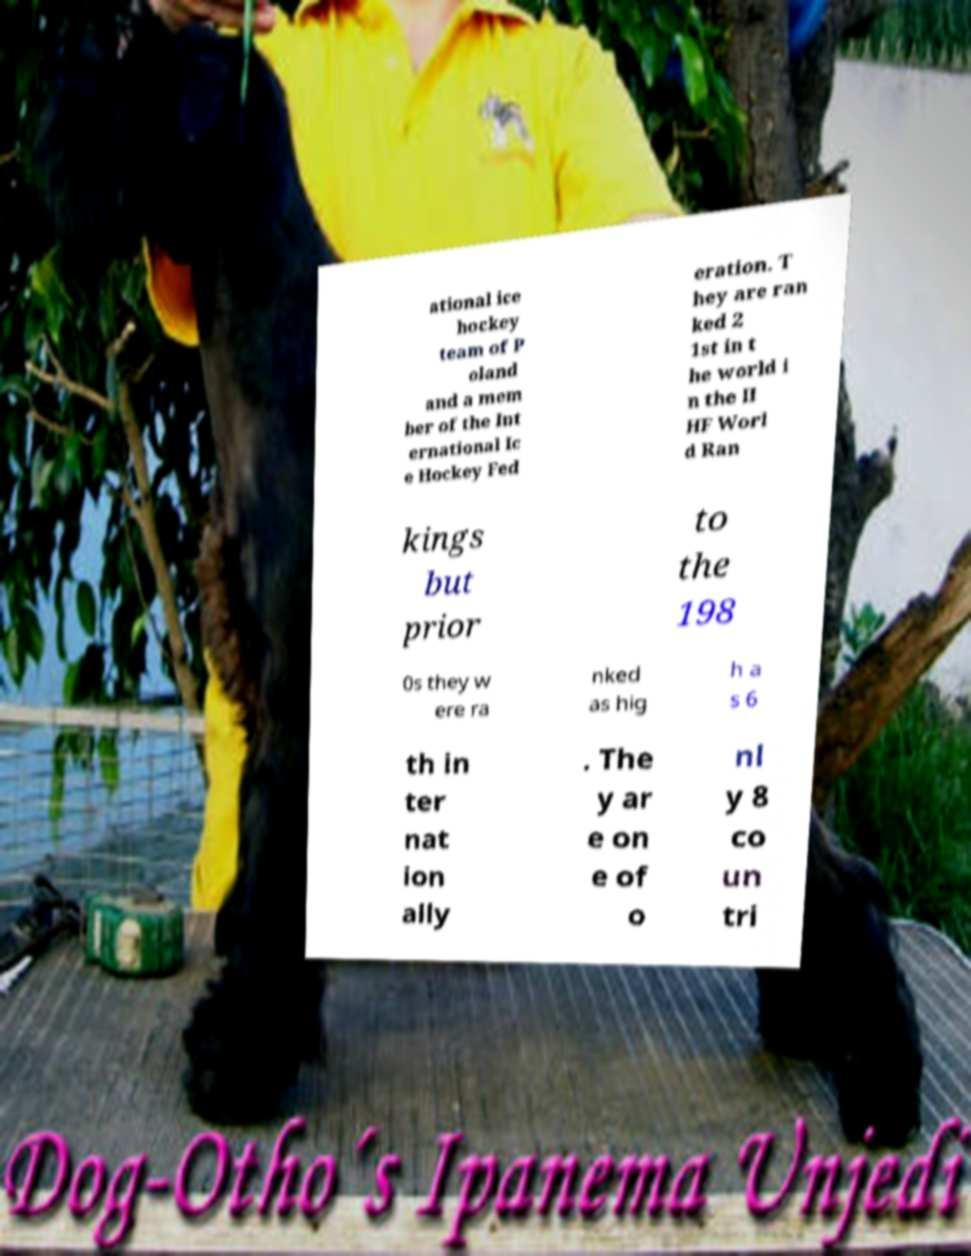Could you assist in decoding the text presented in this image and type it out clearly? ational ice hockey team of P oland and a mem ber of the Int ernational Ic e Hockey Fed eration. T hey are ran ked 2 1st in t he world i n the II HF Worl d Ran kings but prior to the 198 0s they w ere ra nked as hig h a s 6 th in ter nat ion ally . The y ar e on e of o nl y 8 co un tri 